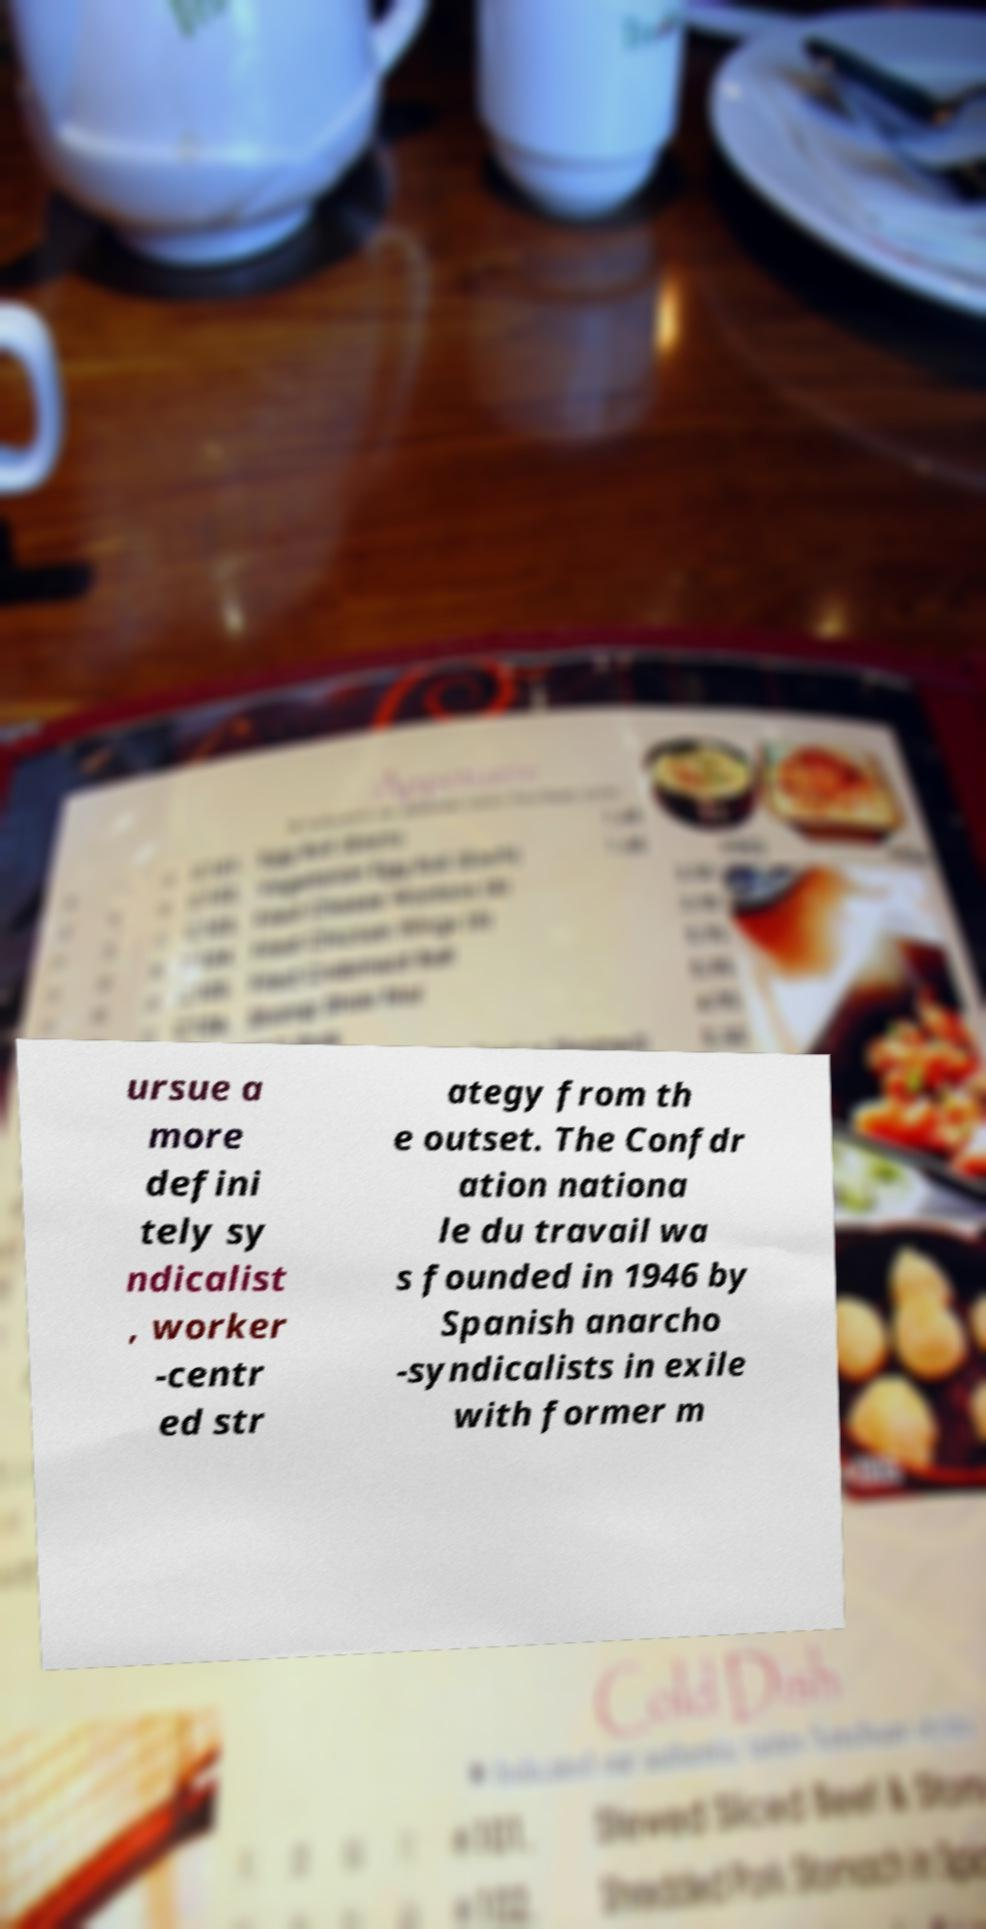I need the written content from this picture converted into text. Can you do that? ursue a more defini tely sy ndicalist , worker -centr ed str ategy from th e outset. The Confdr ation nationa le du travail wa s founded in 1946 by Spanish anarcho -syndicalists in exile with former m 